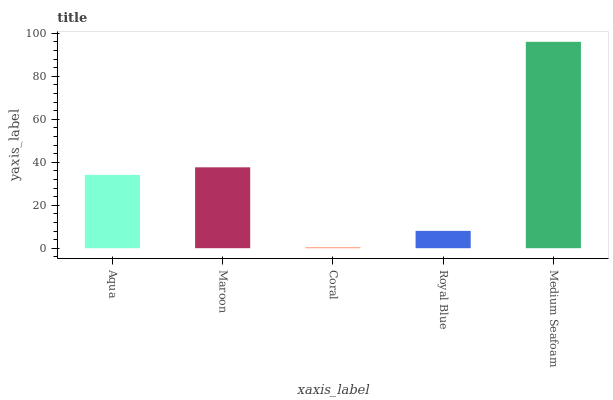Is Coral the minimum?
Answer yes or no. Yes. Is Medium Seafoam the maximum?
Answer yes or no. Yes. Is Maroon the minimum?
Answer yes or no. No. Is Maroon the maximum?
Answer yes or no. No. Is Maroon greater than Aqua?
Answer yes or no. Yes. Is Aqua less than Maroon?
Answer yes or no. Yes. Is Aqua greater than Maroon?
Answer yes or no. No. Is Maroon less than Aqua?
Answer yes or no. No. Is Aqua the high median?
Answer yes or no. Yes. Is Aqua the low median?
Answer yes or no. Yes. Is Coral the high median?
Answer yes or no. No. Is Medium Seafoam the low median?
Answer yes or no. No. 